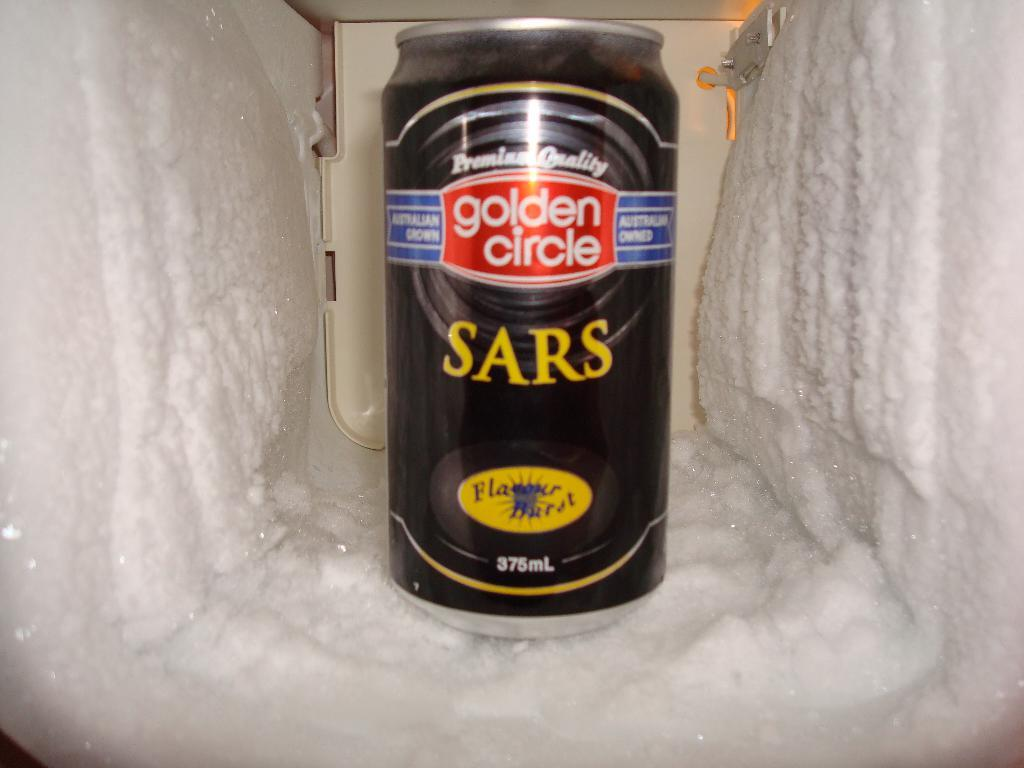<image>
Present a compact description of the photo's key features. A can of Golden Circle SARS flavored beer. 